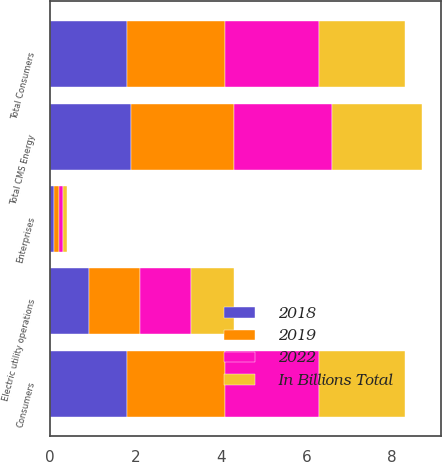Convert chart. <chart><loc_0><loc_0><loc_500><loc_500><stacked_bar_chart><ecel><fcel>Consumers<fcel>Enterprises<fcel>Total CMS Energy<fcel>Electric utility operations<fcel>Total Consumers<nl><fcel>In Billions Total<fcel>2<fcel>0.1<fcel>2.1<fcel>1<fcel>2<nl><fcel>2019<fcel>2.3<fcel>0.1<fcel>2.4<fcel>1.2<fcel>2.3<nl><fcel>2022<fcel>2.2<fcel>0.1<fcel>2.3<fcel>1.2<fcel>2.2<nl><fcel>2018<fcel>1.8<fcel>0.1<fcel>1.9<fcel>0.9<fcel>1.8<nl></chart> 